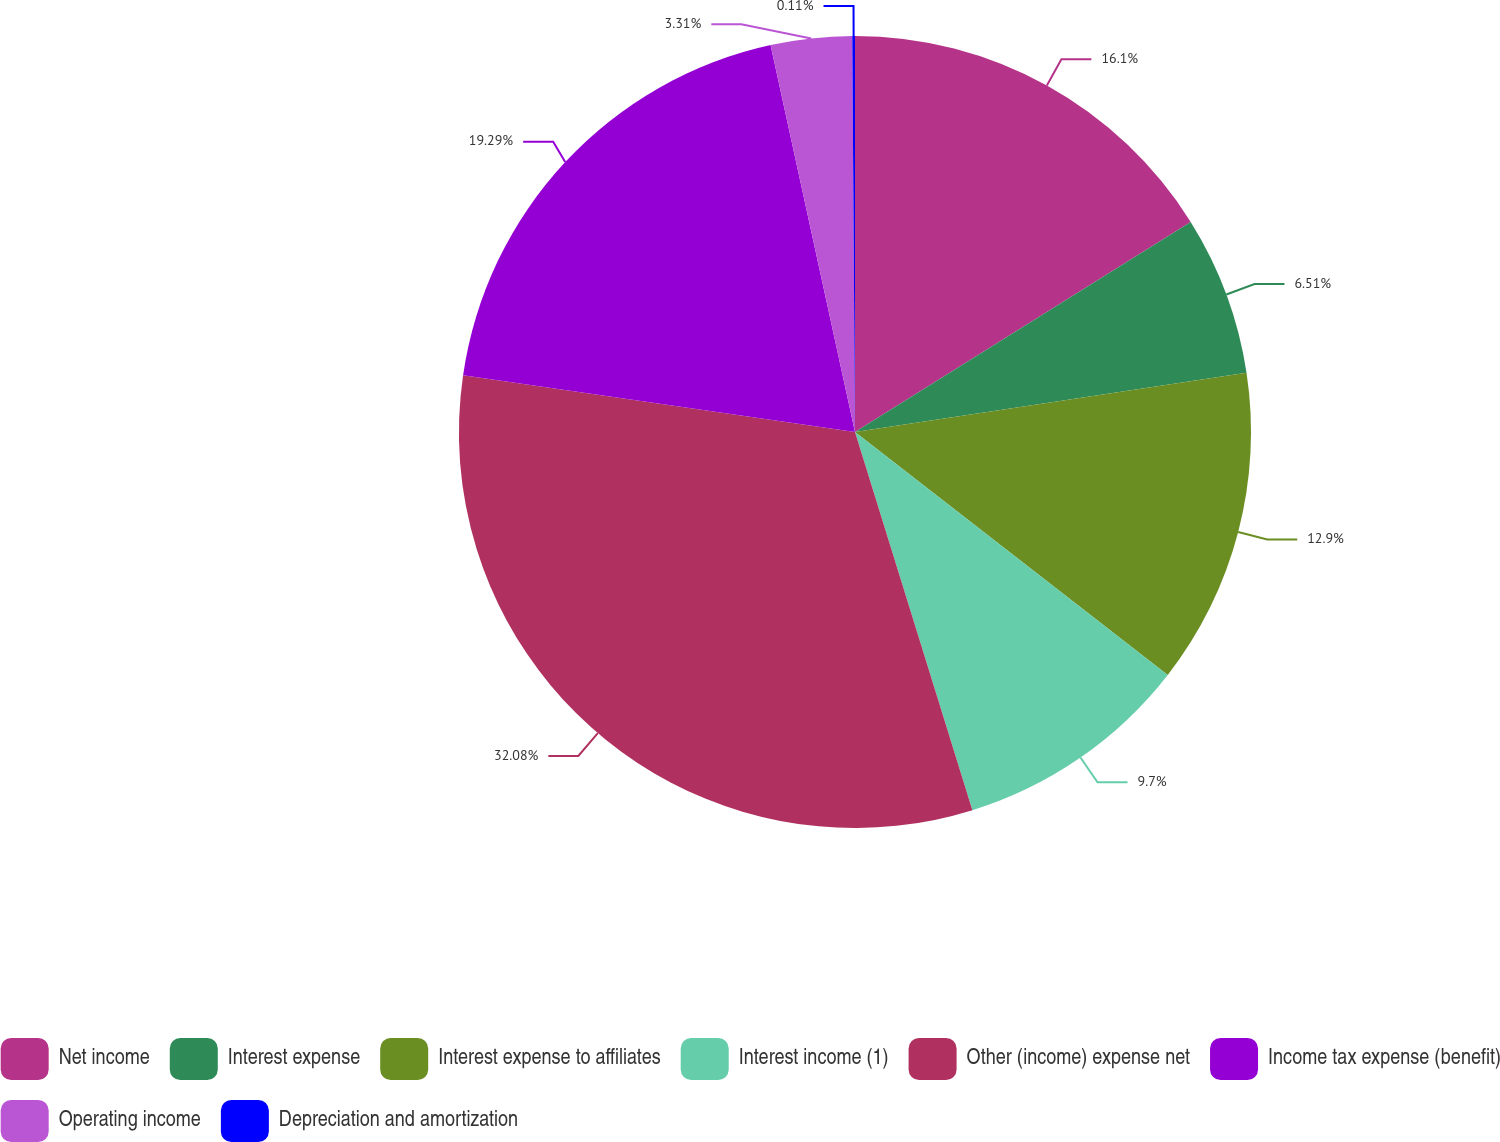Convert chart. <chart><loc_0><loc_0><loc_500><loc_500><pie_chart><fcel>Net income<fcel>Interest expense<fcel>Interest expense to affiliates<fcel>Interest income (1)<fcel>Other (income) expense net<fcel>Income tax expense (benefit)<fcel>Operating income<fcel>Depreciation and amortization<nl><fcel>16.1%<fcel>6.51%<fcel>12.9%<fcel>9.7%<fcel>32.08%<fcel>19.29%<fcel>3.31%<fcel>0.11%<nl></chart> 